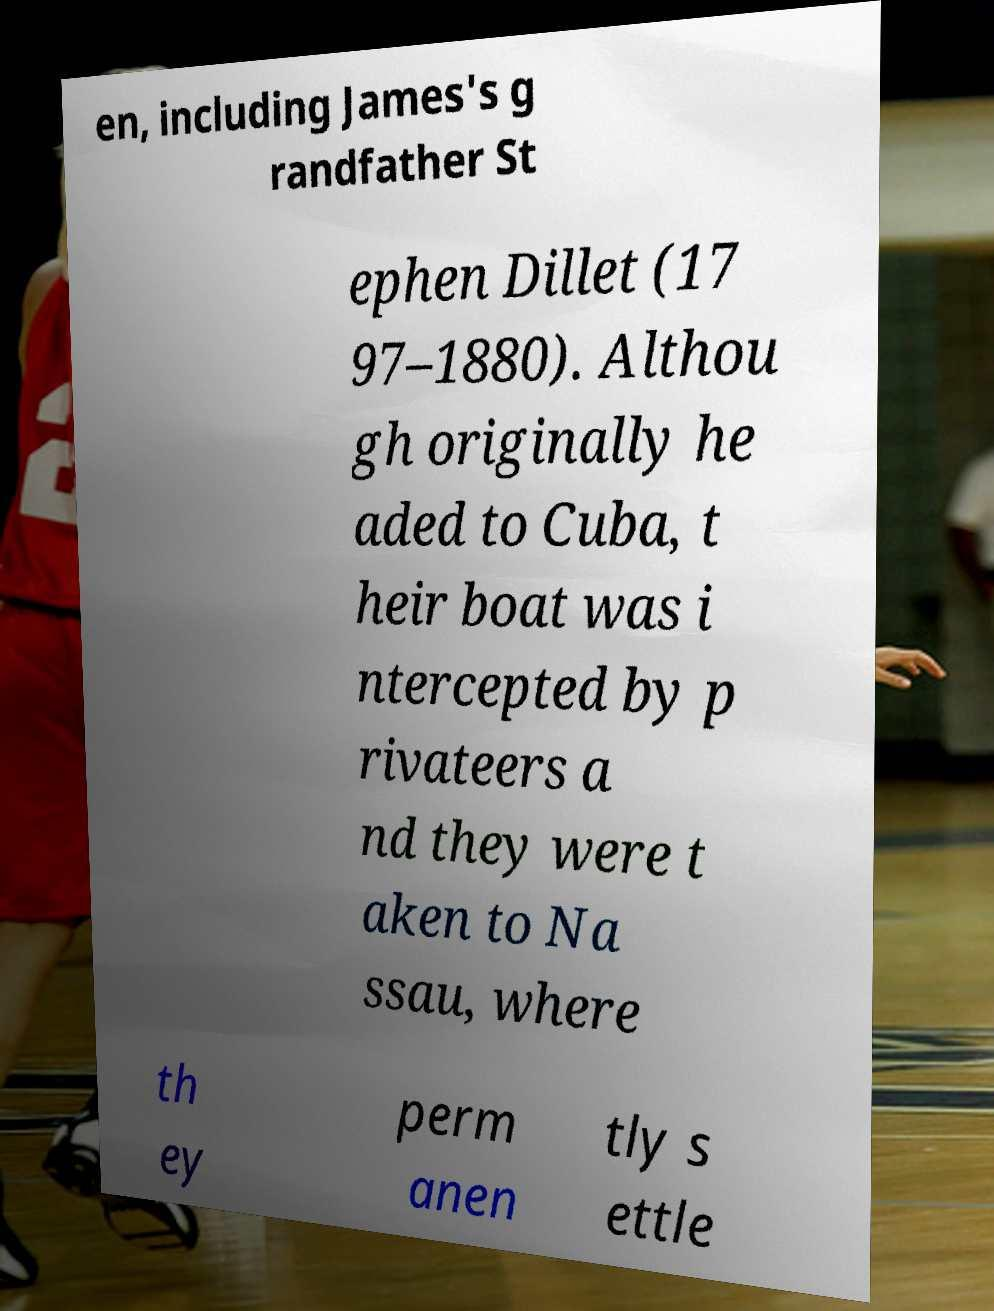Could you assist in decoding the text presented in this image and type it out clearly? en, including James's g randfather St ephen Dillet (17 97–1880). Althou gh originally he aded to Cuba, t heir boat was i ntercepted by p rivateers a nd they were t aken to Na ssau, where th ey perm anen tly s ettle 